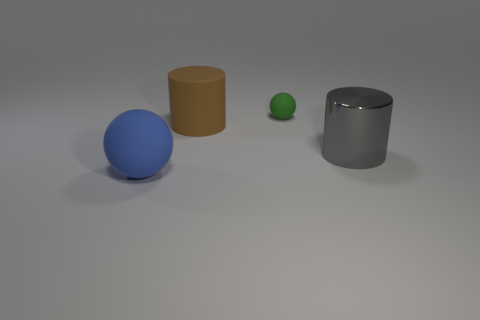Do the ball that is behind the big blue thing and the rubber object that is in front of the large brown thing have the same size?
Your response must be concise. No. What number of objects are rubber spheres or yellow rubber spheres?
Your answer should be compact. 2. What is the size of the matte sphere on the left side of the green rubber thing?
Your answer should be very brief. Large. How many rubber spheres are in front of the rubber object that is to the right of the cylinder that is left of the small rubber object?
Provide a short and direct response. 1. Does the big matte sphere have the same color as the metallic object?
Offer a terse response. No. What number of things are both on the left side of the large gray cylinder and in front of the small green matte ball?
Give a very brief answer. 2. There is a rubber thing in front of the big brown thing; what shape is it?
Your answer should be very brief. Sphere. Are there fewer metal cylinders that are in front of the big shiny thing than metallic things that are on the left side of the big blue object?
Offer a very short reply. No. Does the big cylinder that is in front of the large brown rubber thing have the same material as the object to the left of the brown thing?
Ensure brevity in your answer.  No. What shape is the shiny thing?
Give a very brief answer. Cylinder. 